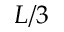Convert formula to latex. <formula><loc_0><loc_0><loc_500><loc_500>L / 3</formula> 